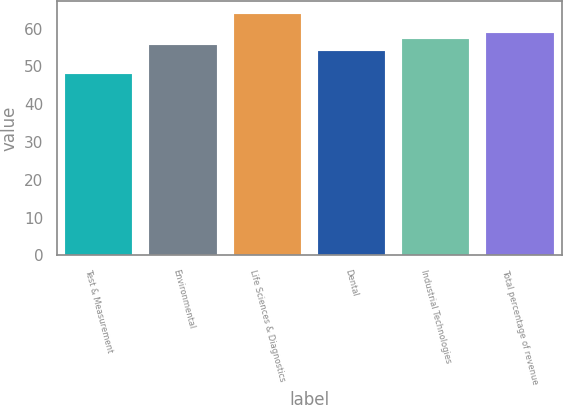<chart> <loc_0><loc_0><loc_500><loc_500><bar_chart><fcel>Test & Measurement<fcel>Environmental<fcel>Life Sciences & Diagnostics<fcel>Dental<fcel>Industrial Technologies<fcel>Total percentage of revenue<nl><fcel>48<fcel>55.6<fcel>64<fcel>54<fcel>57.2<fcel>58.8<nl></chart> 